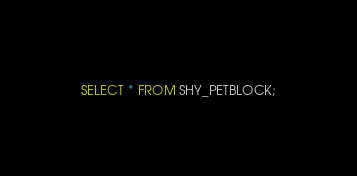Convert code to text. <code><loc_0><loc_0><loc_500><loc_500><_SQL_>SELECT * FROM SHY_PETBLOCK;</code> 